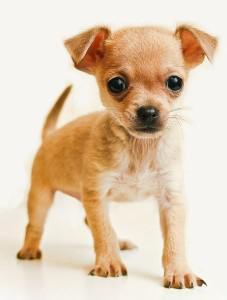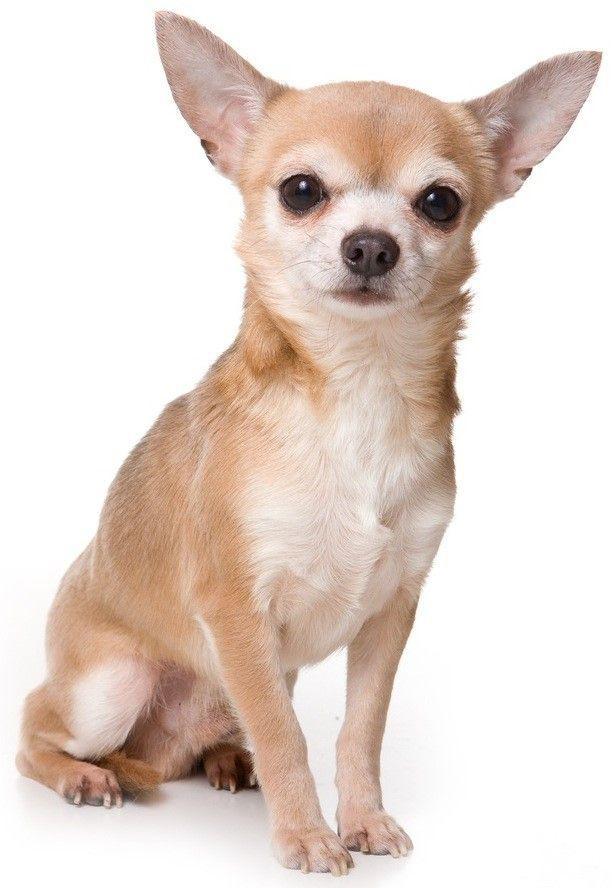The first image is the image on the left, the second image is the image on the right. Analyze the images presented: Is the assertion "Of the two dogs shown, one dog's ears are floppy or folded, and the other dog's ears are pointy and erect." valid? Answer yes or no. Yes. The first image is the image on the left, the second image is the image on the right. Examine the images to the left and right. Is the description "In the right image, a chihuahua is wearing an object around its neck." accurate? Answer yes or no. No. 